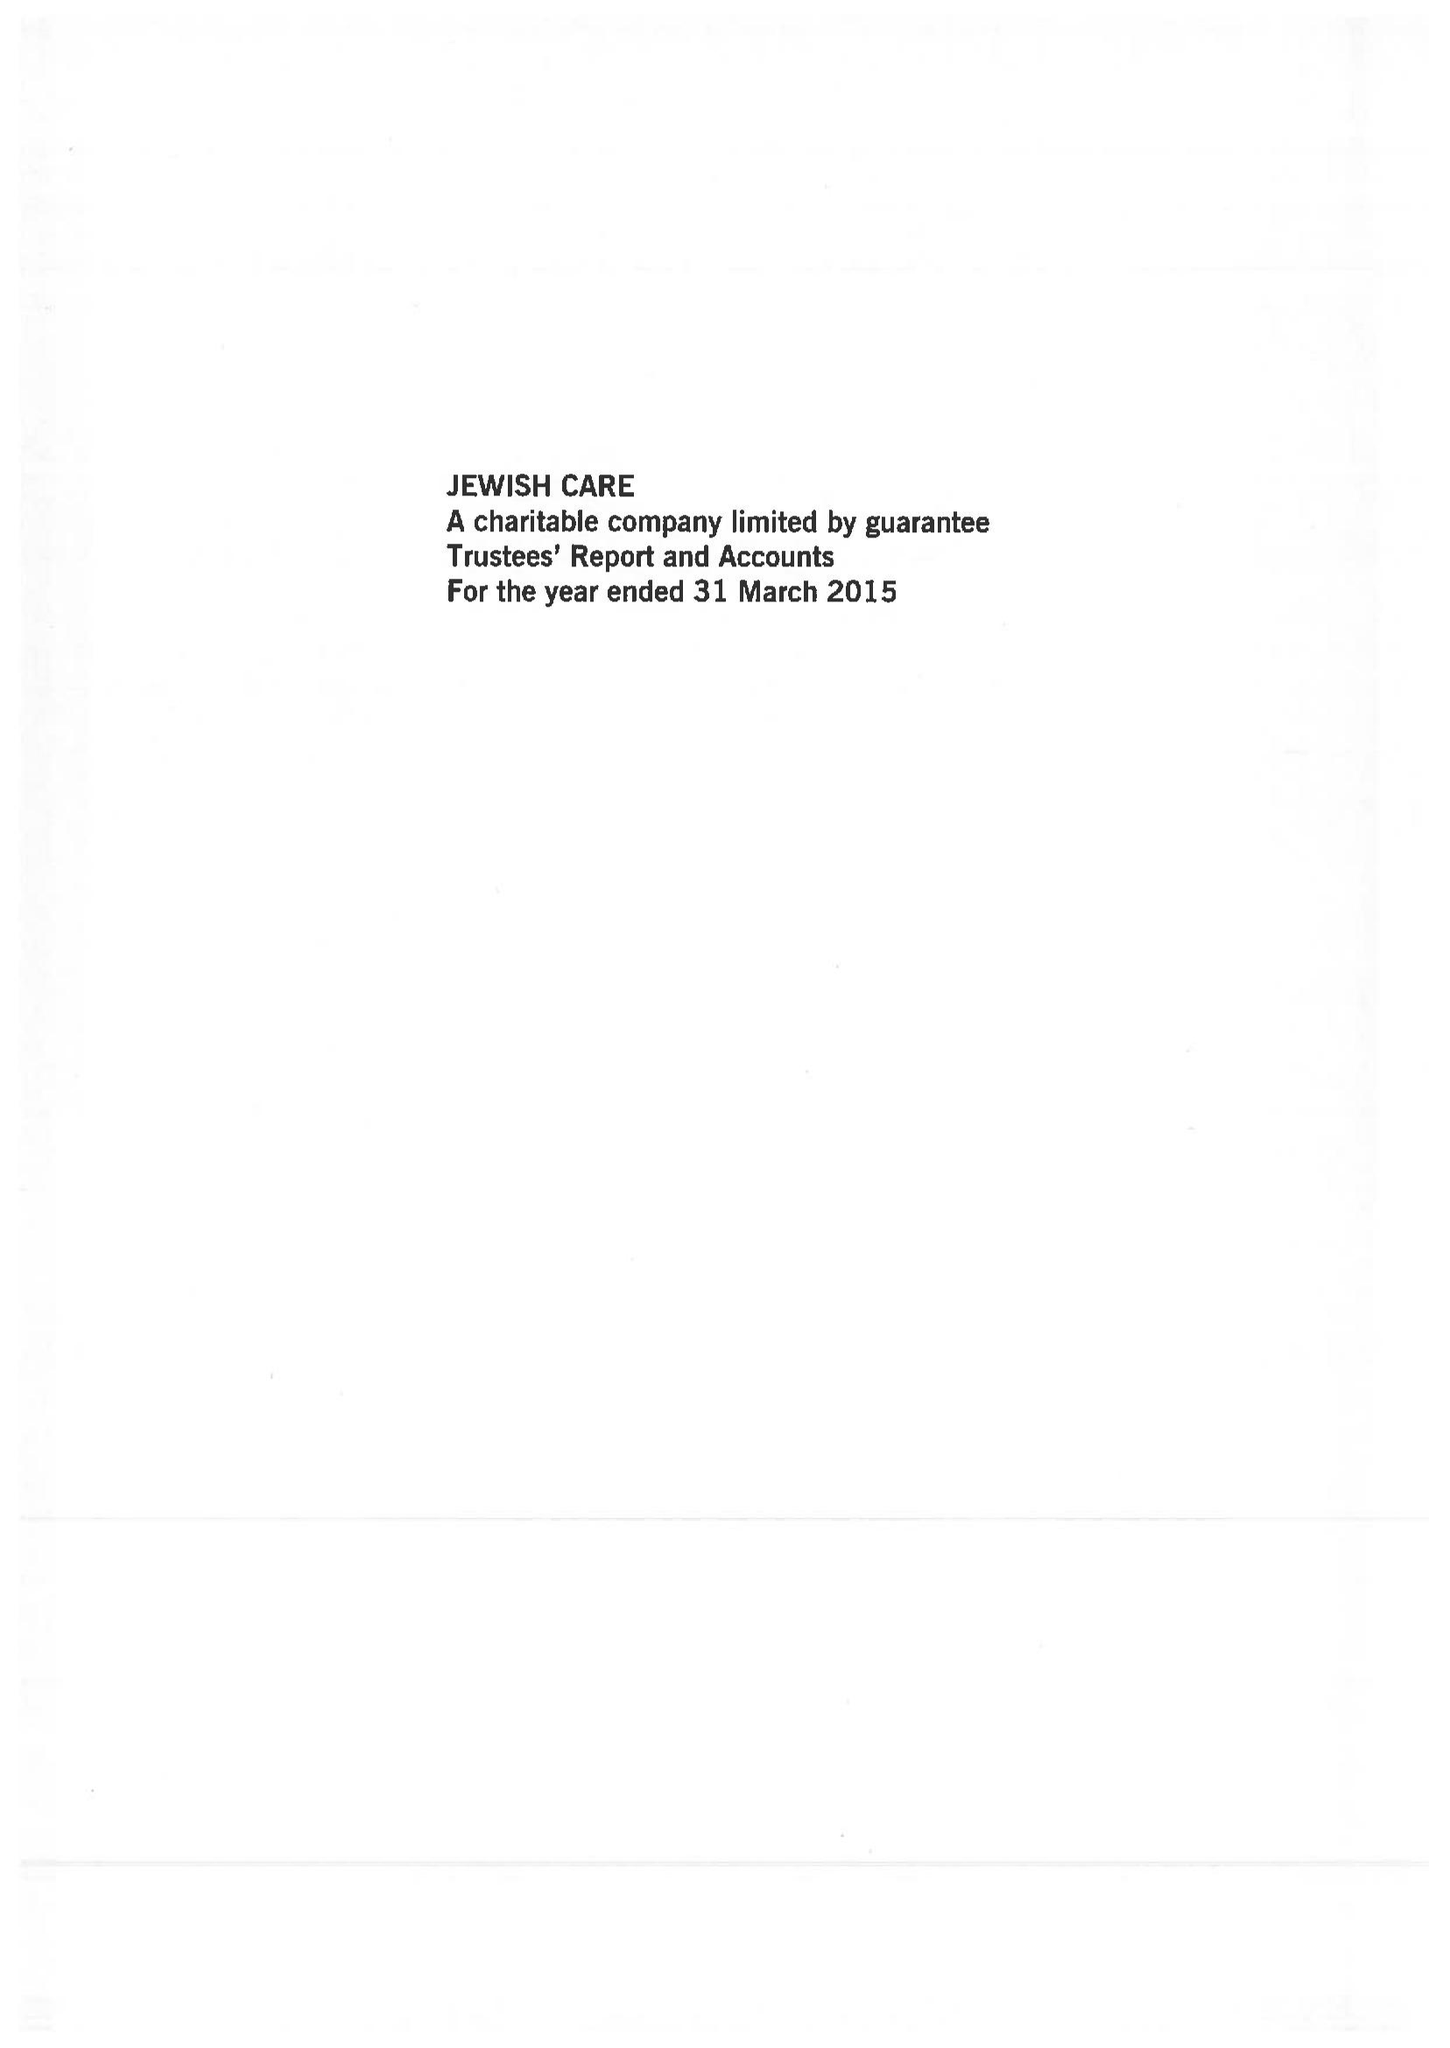What is the value for the charity_number?
Answer the question using a single word or phrase. 802559 